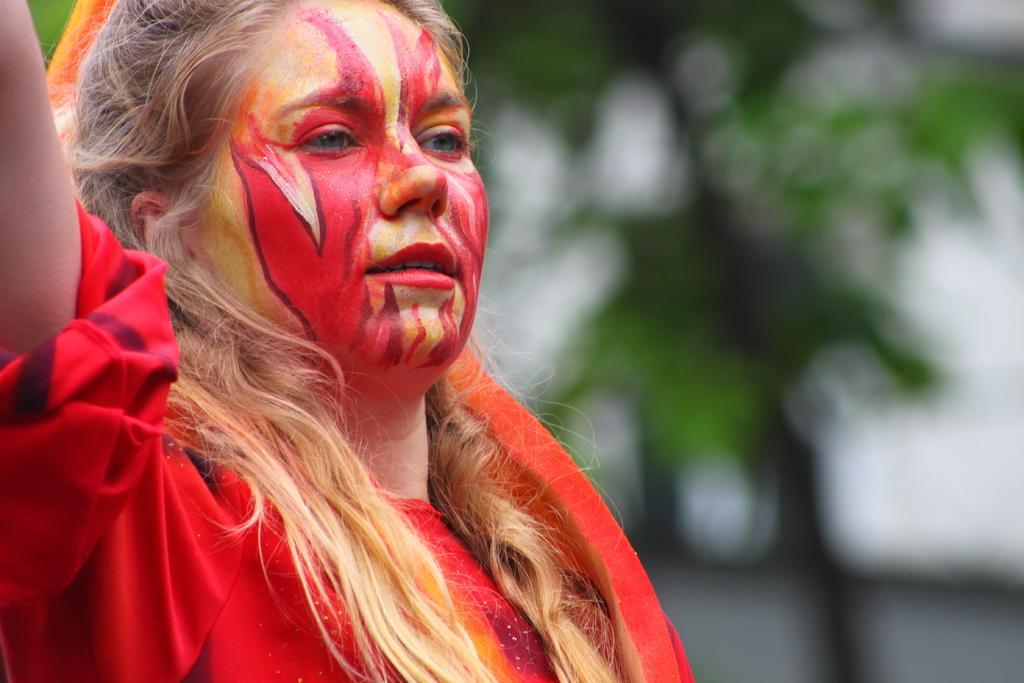In one or two sentences, can you explain what this image depicts? In this picture, we see the girl wearing a red dress. We see paint on her face. In the background, it is green in color and it is blurred in the background. 